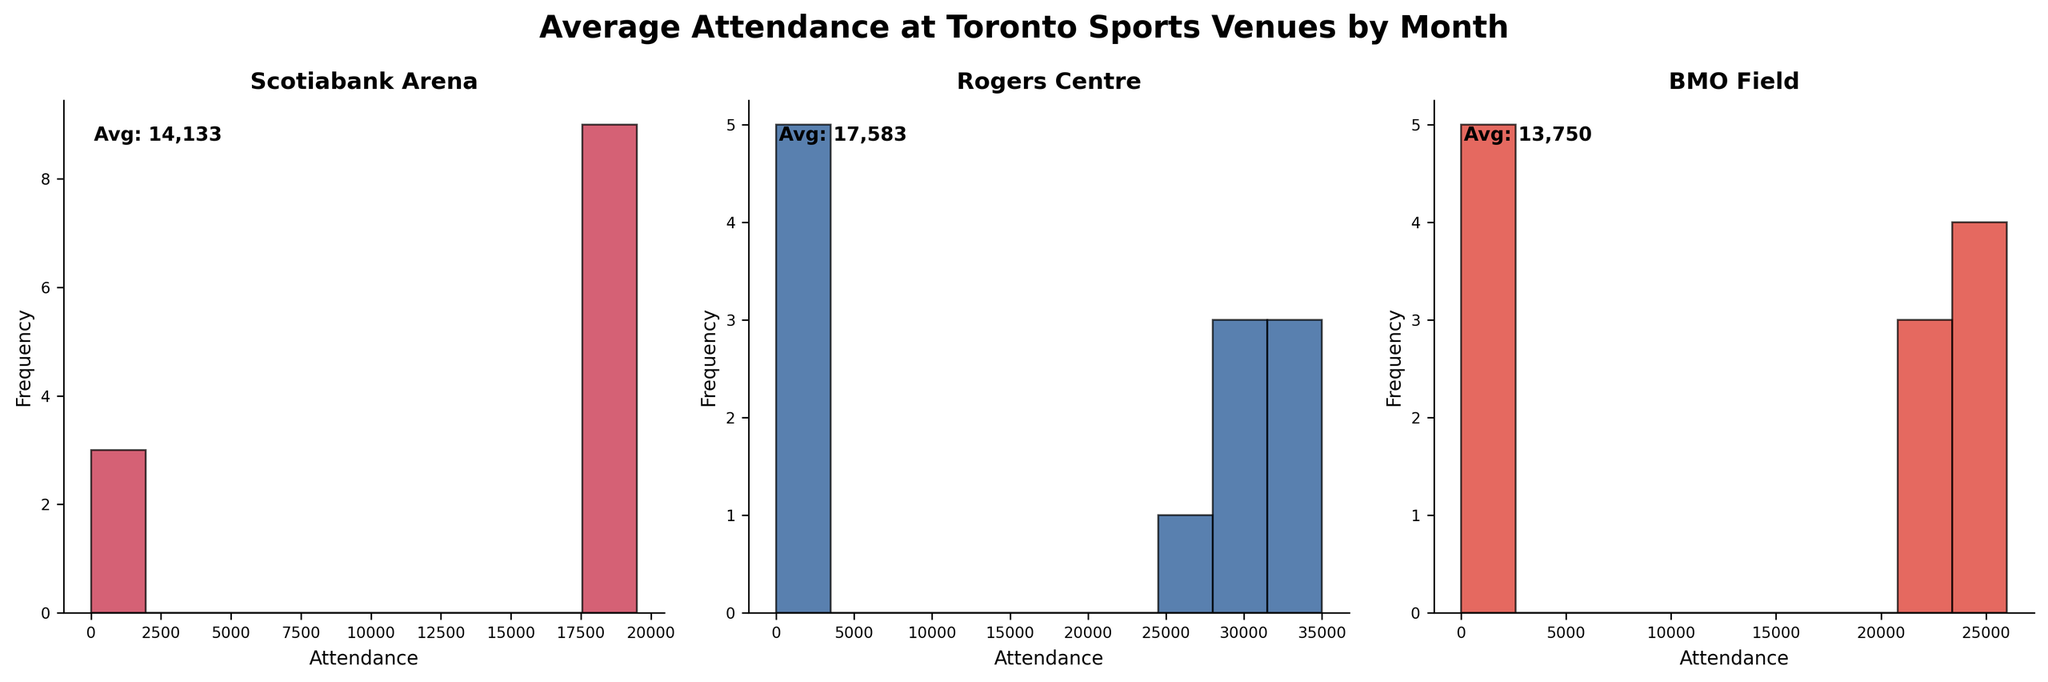what is the title of the plot? The title is displayed at the top of the figure, describing the content of the plot.
Answer: Average Attendance at Toronto Sports Venues by Month Which venue has the highest average attendance? The average attendance is indicated in each subplot. Scotiabank Arena's is 18,900, Rogers Centre's is 31,000, and BMO Field's is 24,000, so the highest is Rogers Centre.
Answer: Rogers Centre How many subplots are present in the figure? By counting the distinct histogram graphs within the figure, we find there are three separate subplots.
Answer: 3 How does the average attendance in July compare across all venues? In July, Scotiabank Arena has 0 attendance, Rogers Centre has 35,000, and BMO Field has 25,000. So, Rogers Centre has the highest.
Answer: Rogers Centre Which venue has the least variability in attendance? The variability is visually represented by the spread of attendance in each histogram. Scotiabank Arena has the narrowest spread, with most values close to its average of 18,900.
Answer: Scotiabank Arena What is the average attendance at BMO Field? In the BMO Field subplot, an average attendance value of 24,000 is annotated at the top left corner of the histogram.
Answer: 24,000 Which months have zero attendance for Rogers Centre? By looking at the histogram for Rogers Centre, the months with zero attendance are highlighted in the data for January, February, March, November, and December.
Answer: January, February, March, November, December How does Scotiabank Arena's highest attendance value compare to BMO Field's lowest attendance value? Scotiabank Arena's highest attendance is in May at 19,500, and the lowest attendance for BMO Field is in November at 21,000. Scotiabank Arena's highest is less.
Answer: Less What colors are used for each venue's histogram? The colors can be identified visually in each subplot: Scotiabank Arena (red), Rogers Centre (blue), BMO Field (darker red).
Answer: Scotiabank Arena - red, Rogers Centre - blue, BMO Field - darker red Which stadium has an average attendance that is closest to 20,000? By checking the average attendance values displayed on each subplot, we see that Scotiabank Arena has an average of 18,900, which is the closest to 20,000.
Answer: Scotiabank Arena 